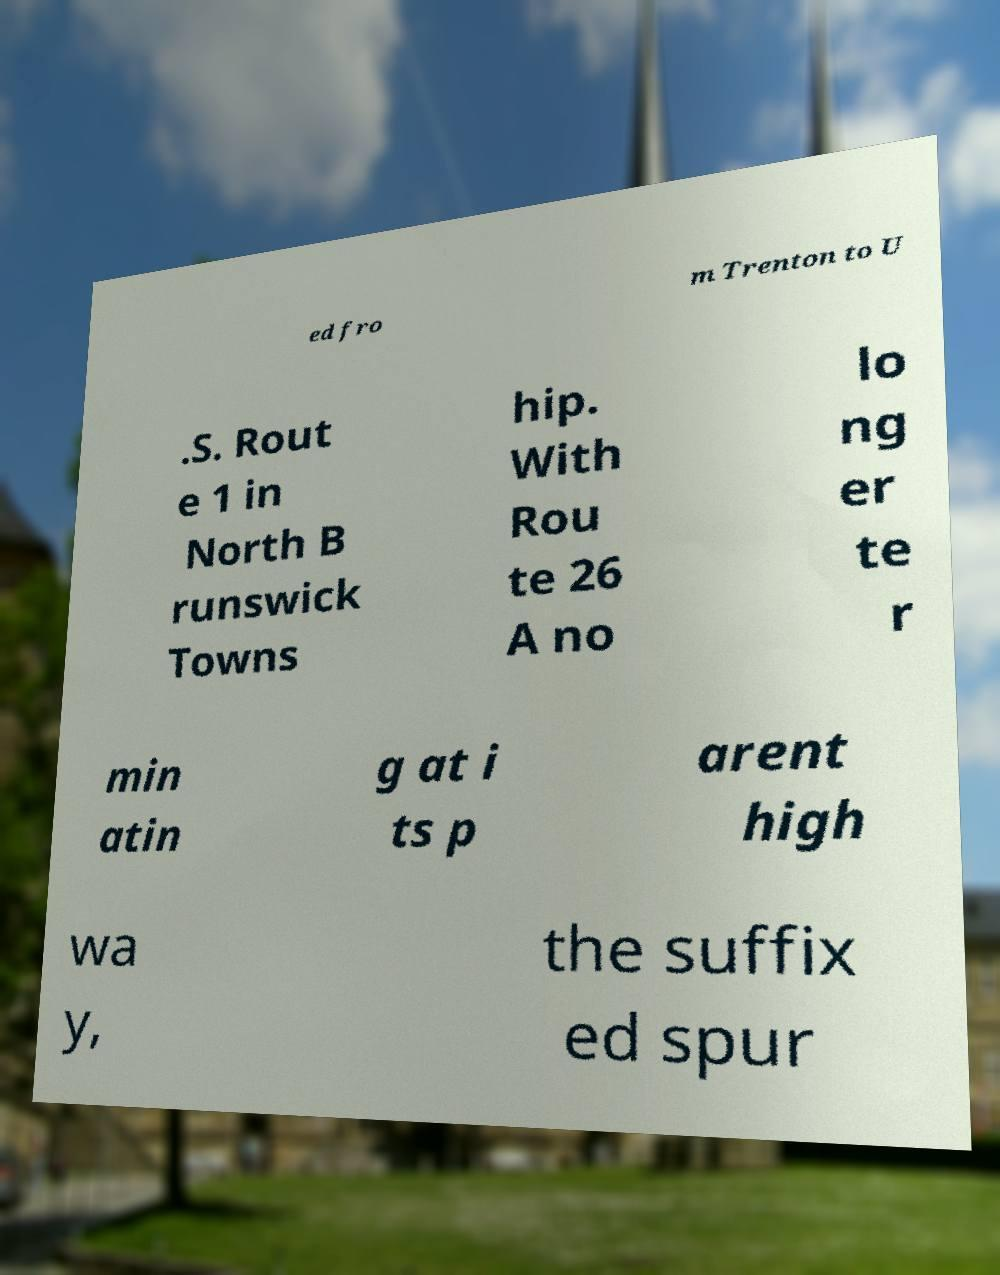For documentation purposes, I need the text within this image transcribed. Could you provide that? ed fro m Trenton to U .S. Rout e 1 in North B runswick Towns hip. With Rou te 26 A no lo ng er te r min atin g at i ts p arent high wa y, the suffix ed spur 